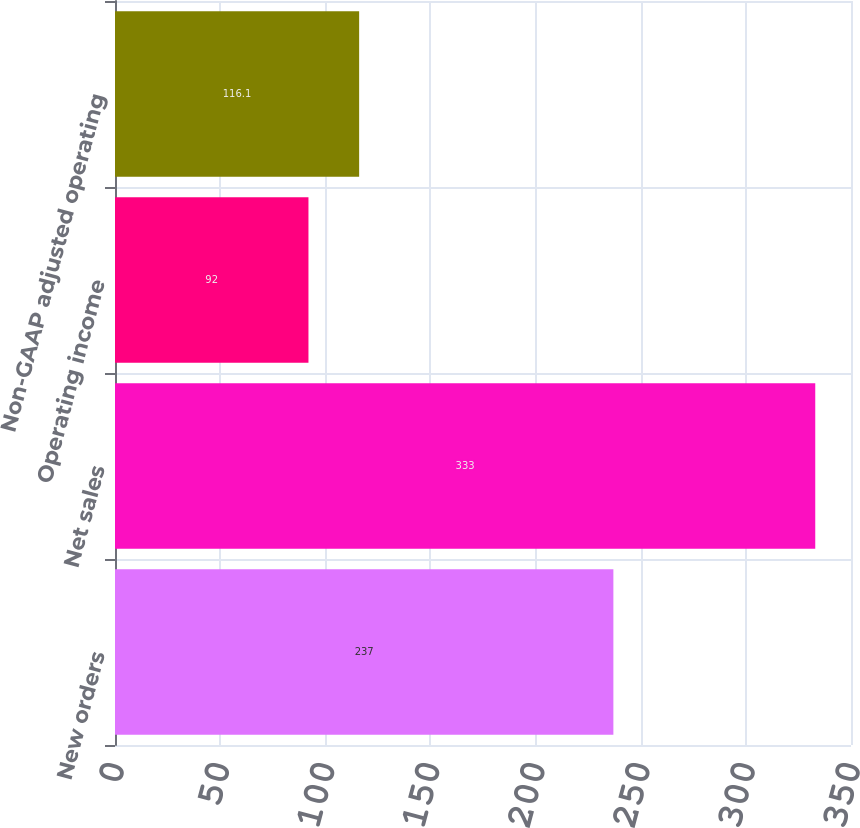Convert chart to OTSL. <chart><loc_0><loc_0><loc_500><loc_500><bar_chart><fcel>New orders<fcel>Net sales<fcel>Operating income<fcel>Non-GAAP adjusted operating<nl><fcel>237<fcel>333<fcel>92<fcel>116.1<nl></chart> 